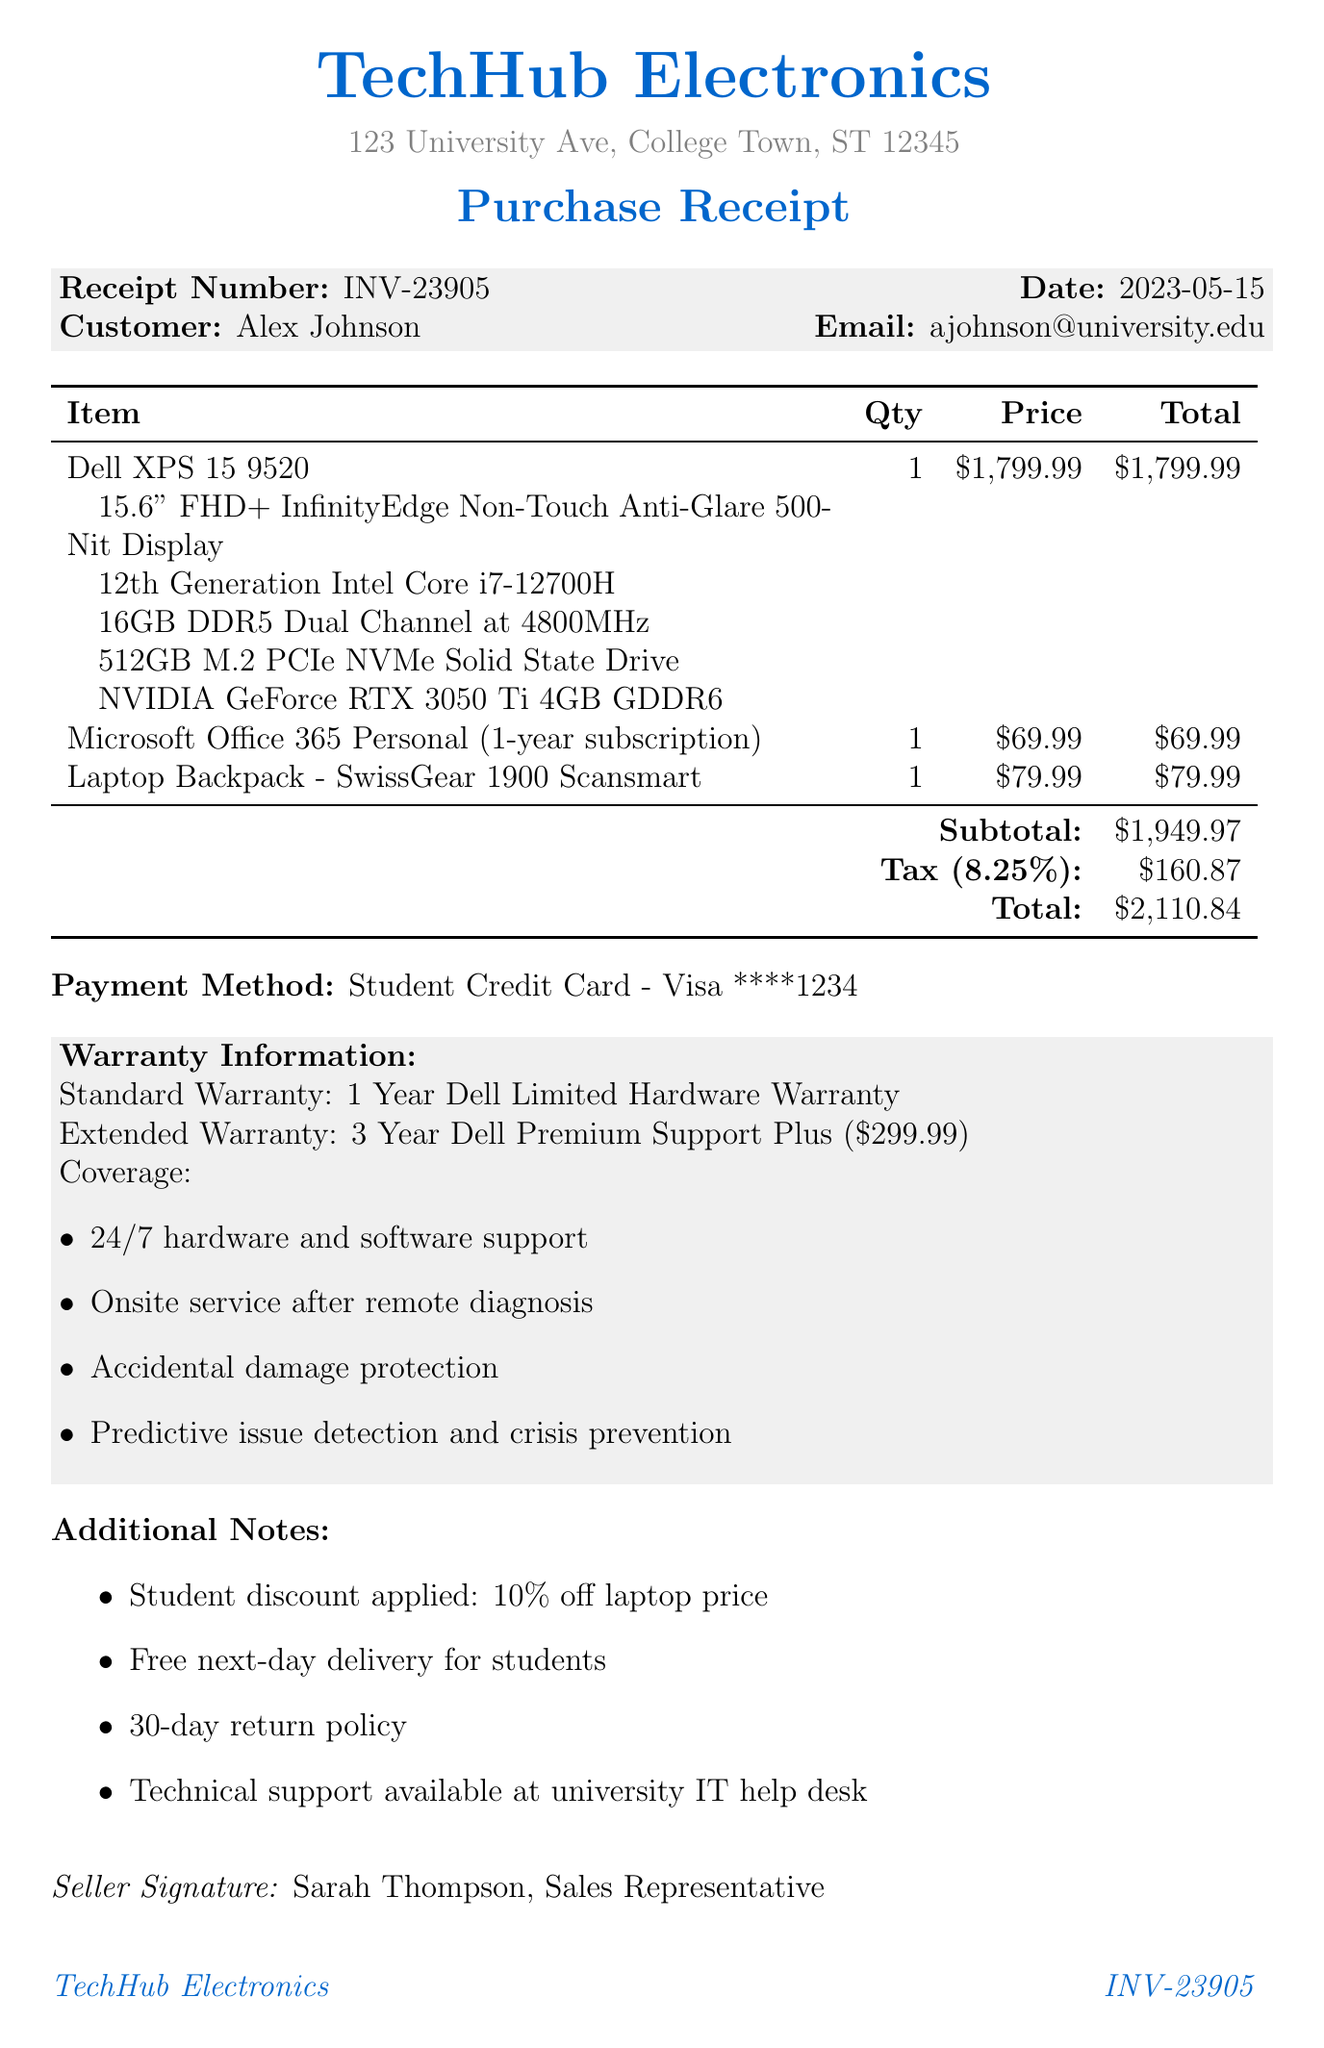What is the receipt number? The receipt number is a unique identifier for this purchase transaction and is listed at the top of the receipt.
Answer: INV-23905 What is the date of purchase? The date of purchase indicates when the transaction took place, which is shown on the receipt.
Answer: 2023-05-15 Who is the customer? The customer's name is provided to identify who made the purchase, clearly stated in the receipt.
Answer: Alex Johnson What is the total amount paid? The total amount represents the entire cost of the items including tax, summarized at the bottom of the receipt.
Answer: 2110.84 What kind of warranty is standard? The warranty information specifies the coverage included with the purchase and includes both standard and extended options.
Answer: 1 Year Dell Limited Hardware Warranty How much is the extended warranty price? The extended warranty price is clearly listed alongside the warranty information, indicating the cost for additional coverage.
Answer: 299.99 What item has a subscription duration of one year? The items listed include software with a subscription, which is indicated by its name and details.
Answer: Microsoft Office 365 Personal (1-year subscription) What payment method was used? The payment method describes how the transaction was completed, specifically noting the type of card used.
Answer: Student Credit Card - Visa ****1234 What student benefit is mentioned in the additional notes? The additional notes highlight special benefits for students, which are also clearly stated in the receipt.
Answer: Free next-day delivery for students 